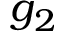Convert formula to latex. <formula><loc_0><loc_0><loc_500><loc_500>g _ { 2 }</formula> 